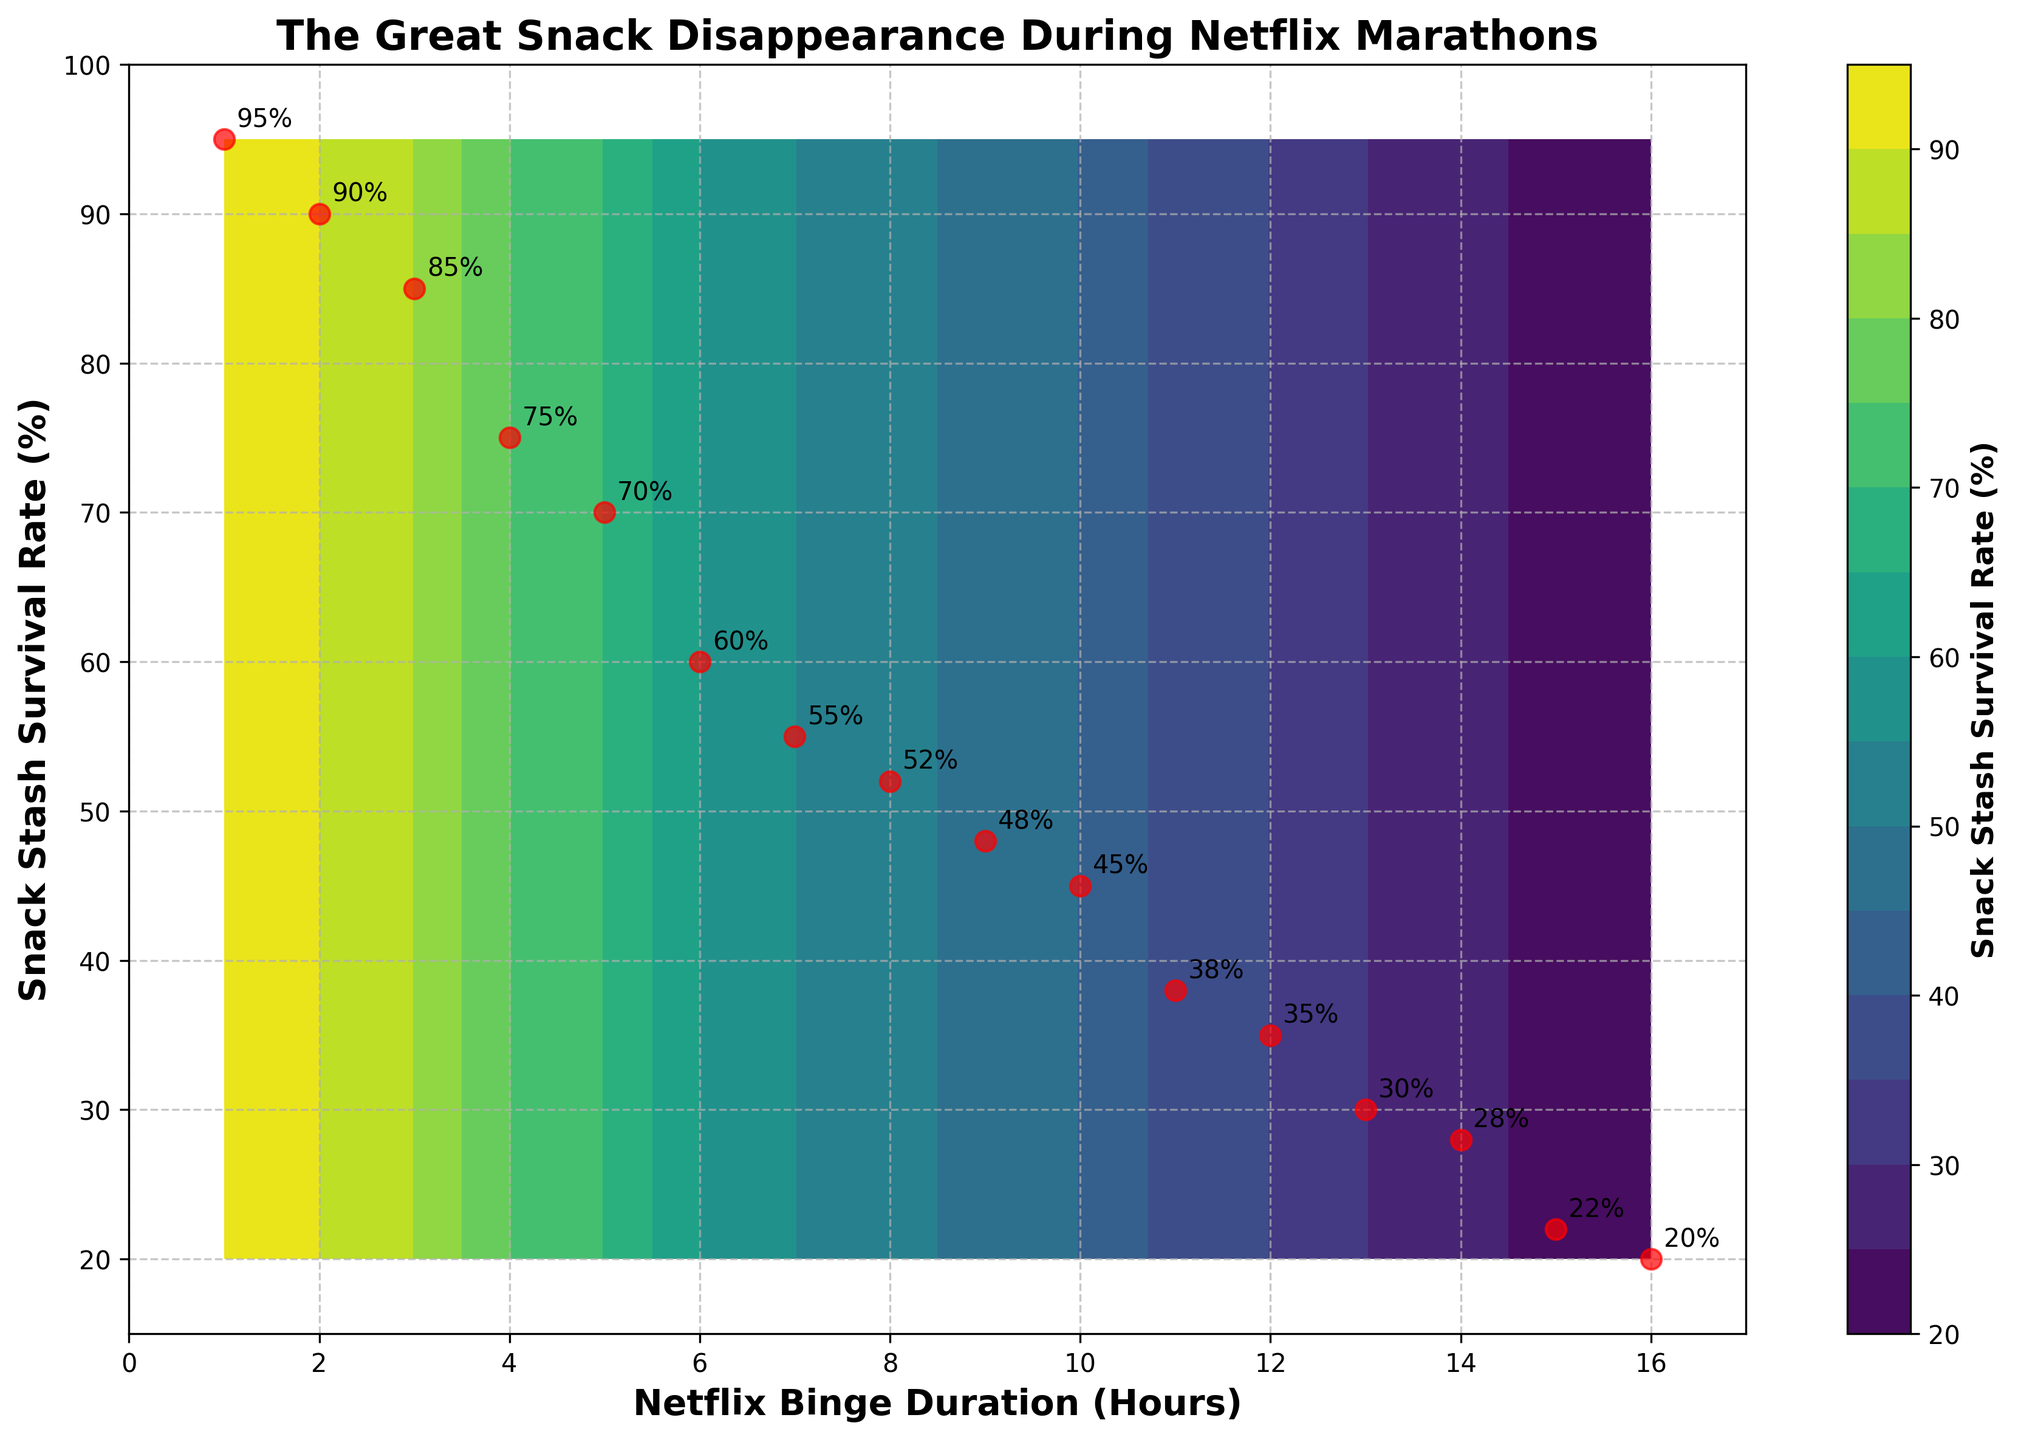What is the title of the plot? The title is stated at the top of the figure and gives a humorous indication of the scenario depicted.
Answer: The Great Snack Disappearance During Netflix Marathons How many data points are shown in red on the plot? The red points are the actual data points marked on the plot. Count the red circles.
Answer: 16 What is the color of the contour regions? Look at the contour areas filled within the plot, which shows a gradient. The dominant palette will be most noticeable.
Answer: Shades of green and blue (viridis) What is the Snack Stash Survival Rate when the Netflix Binge Duration is 7 hours? Locate '7 hours' on the x-axis and look at the corresponding y-axis value or the data label annotated nearby.
Answer: 55% At what duration of Netflix binge does the Snack Stash Survival Rate cross below 50%? Find the point where the y-axis values drop below 50% by tracing horizontally from the values on the y-axis.
Answer: 9 hours What is the average Snack Stash Survival Rate for binge durations from 5 to 10 hours? Collect the survival rates for 5 to 10 hours, sum these values, and divide by the number of data points. (70 + 60 + 55 + 52 + 48 + 45)/6 = 330/6
Answer: 55% Are there any duration hours where the snack rate stays constant or shows a minor dip? Identify any flat or slightly declining parts on the curve where the survival rate changes minimally.
Answer: Between 12 and 14 hours Which Netflix binge duration correlates with the lowest Snack Stash Survival Rate among the data points provided? Identify the smallest y-value among the annotated data points.
Answer: 16 hours What's the difference in Snack Stash Survival Rate between a 1-hour binge and a 10-hour binge? Refer to the y-values for 1-hour and 10-hour durations, then subtract these values (95 - 45).
Answer: 50% Describe the trend of the Snack Stash Survival Rate as the Netflix binge duration increases. Examine the slope and flow of the survival rate curve as it moves from left (shorter duration) to right (longer duration).
Answer: The rate decreases steadily over time 